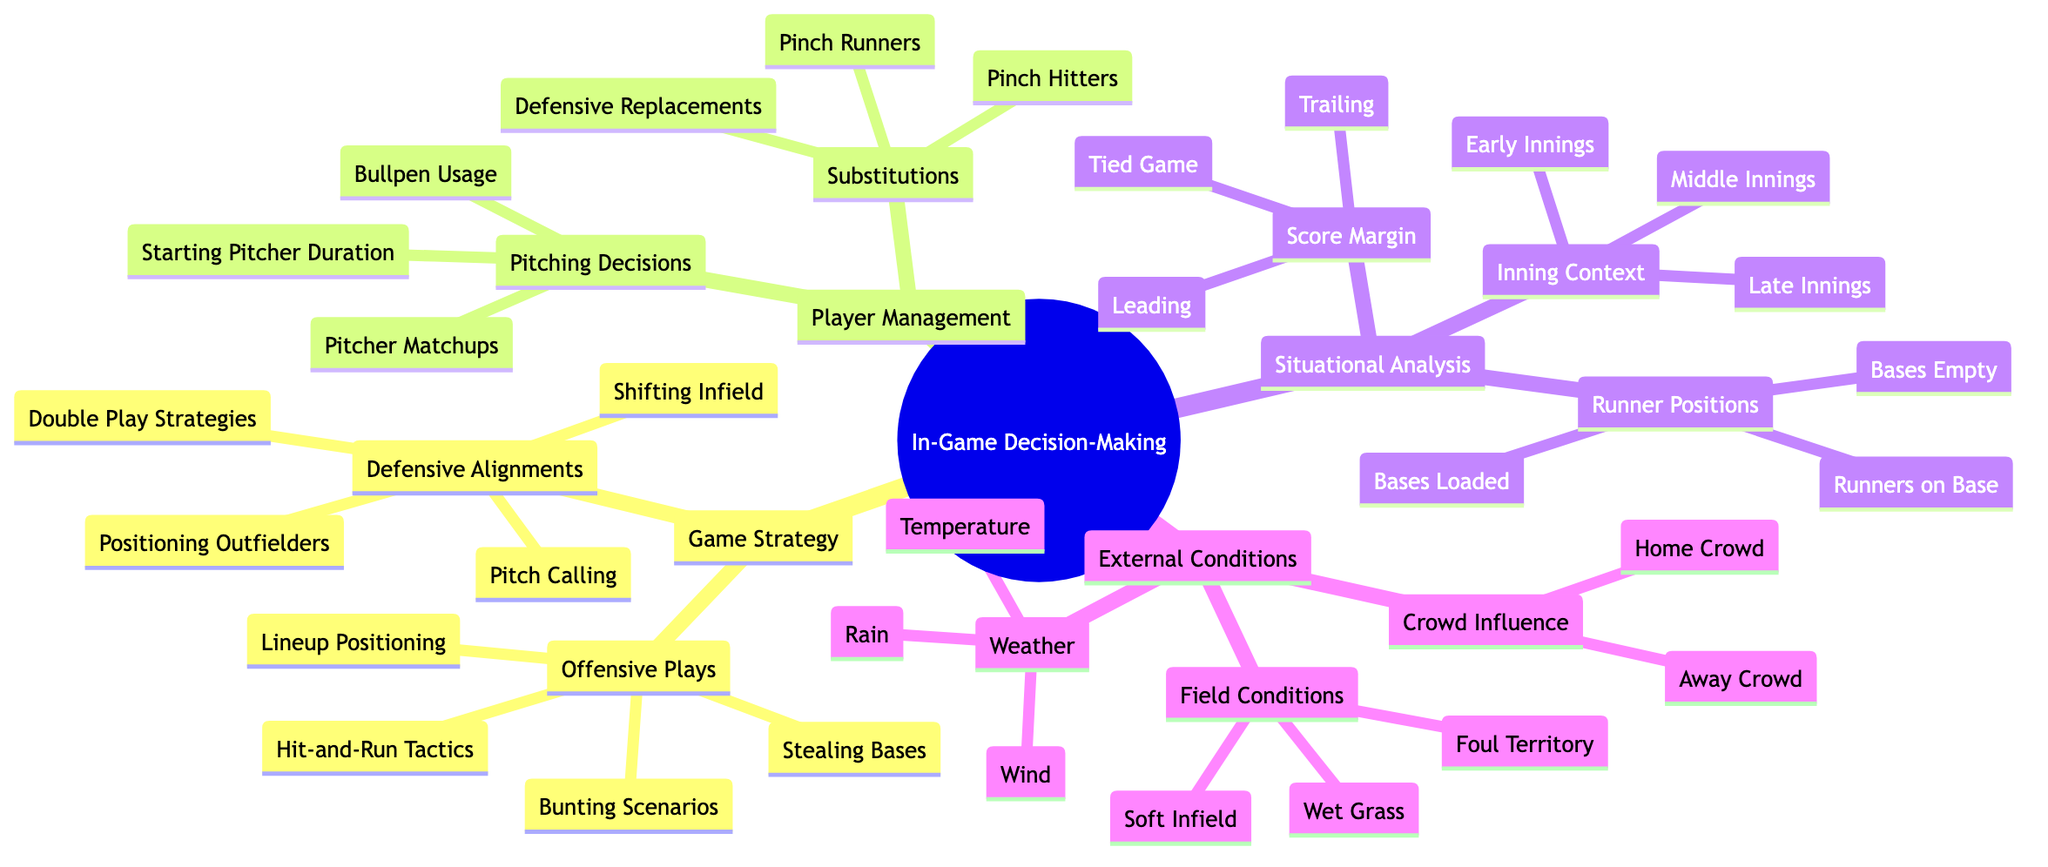What are the two main categories of In-Game Decision-Making Processes? The diagram shows "Game Strategy" and "Player Management" as the first two branches of the Mind Map. They represent the primary categories under In-Game Decision-Making Processes.
Answer: Game Strategy, Player Management How many types of Offensive Plays are listed? By counting the items under "Offensive Plays", we find that there are four: "Hit-and-Run Tactics," "Bunting Scenarios," "Stealing Bases," and "Lineup Positioning."
Answer: 4 What situational context is considered when the score is tied? The node under "Situational Analysis" shows "Tied Game" as one of the contexts related to "Score Margin," which represents the state of the game when scores are equal.
Answer: Tied Game What external condition can influence player decisions? The "External Conditions" branch lists factors like "Weather," "Field Conditions," and "Crowd Influence," indicating these conditions affect in-game decisions.
Answer: Weather, Field Conditions, Crowd Influence Which pitching decision involves the use of relief pitchers? "Bullpen Usage" is identified under "Pitching Decisions," highlighting the strategy of calling in relief pitchers during the game.
Answer: Bullpen Usage What are the three scenarios listed under Runner Positions? The diagram outlines "Bases Empty," "Runners on Base," and "Bases Loaded" under the "Runner Positions" category, indicating different situations during the game.
Answer: Bases Empty, Runners on Base, Bases Loaded Which type of alignments is deployed for defensive strategies? "Defensive Alignments" is a main branch that provides specific strategies such as "Shifting Infield" and "Positioning Outfielders," indicating tactical decisions in defense.
Answer: Shifting Infield, Positioning Outfielders In which inning context would you typically use "Pinch Hitters"? "Pinch Hitters" is categorized under "Substitutions." While not explicitly tied to a specific inning, Pinch Hitters are often used most effectively in later innings when trying to make a crucial scoring play.
Answer: Late Innings What is one type of weather condition that can affect the game? The weather influences game dynamics, with "Rain" listed under "Weather;" it potentially impacts player performance and field conditions.
Answer: Rain 